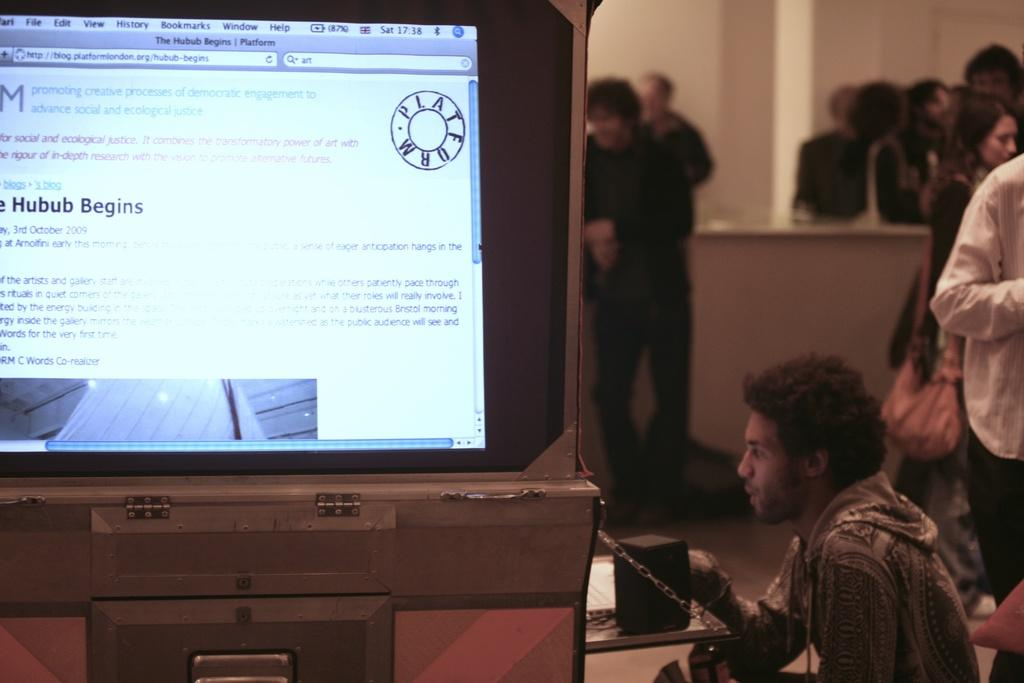What are the people in the image doing? The people in the image are standing. What is the person in front of the table doing? The person is sitting. What is on the table in the image? The table has speakers and a screen on it. What can be seen in the background of the image? There is a pillar and a wall in the background. Can you tell me how many berries are on the table in the image? There are no berries present on the table in the image. Is there a trail visible in the image? There is no trail visible in the image. 